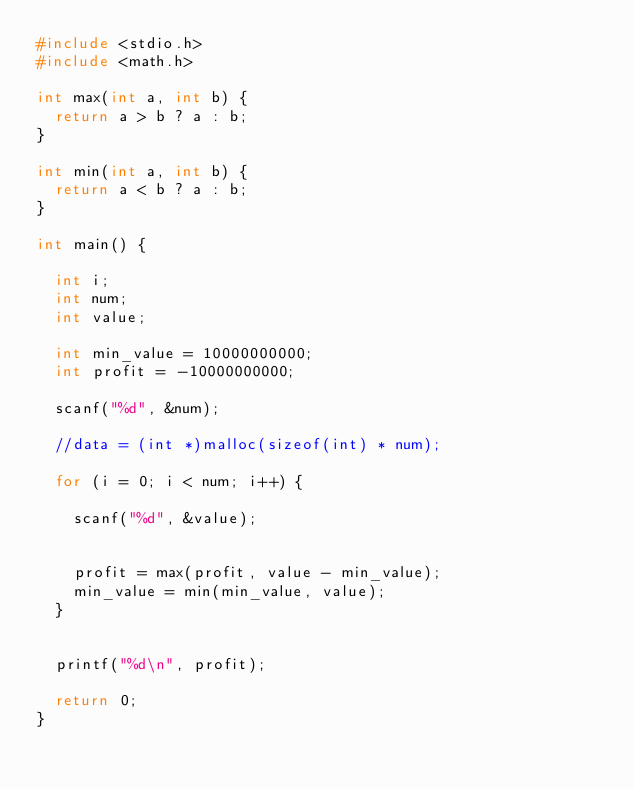<code> <loc_0><loc_0><loc_500><loc_500><_C_>#include <stdio.h>
#include <math.h>

int max(int a, int b) {
	return a > b ? a : b;
}

int min(int a, int b) {
	return a < b ? a : b;
}

int main() {

	int i;
	int num;
	int value;

	int min_value = 10000000000;
	int profit = -10000000000;

	scanf("%d", &num);

	//data = (int *)malloc(sizeof(int) * num);

	for (i = 0; i < num; i++) {

		scanf("%d", &value);

		
		profit = max(profit, value - min_value);
		min_value = min(min_value, value);
	}


	printf("%d\n", profit);

	return 0;
}</code> 